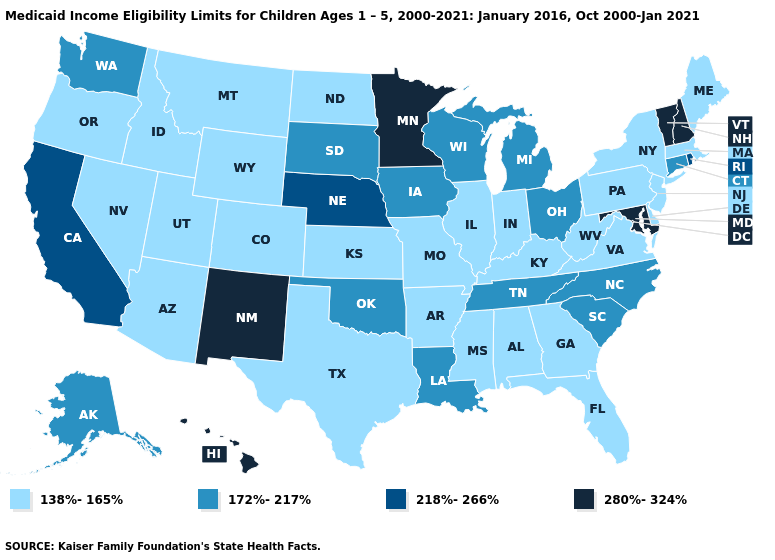Among the states that border New Mexico , which have the lowest value?
Write a very short answer. Arizona, Colorado, Texas, Utah. What is the value of Massachusetts?
Quick response, please. 138%-165%. Among the states that border Vermont , does New York have the highest value?
Write a very short answer. No. What is the highest value in the West ?
Be succinct. 280%-324%. What is the value of Washington?
Be succinct. 172%-217%. Does Maryland have the highest value in the South?
Give a very brief answer. Yes. What is the value of New Jersey?
Keep it brief. 138%-165%. Does New Jersey have the highest value in the USA?
Concise answer only. No. What is the highest value in the South ?
Keep it brief. 280%-324%. What is the value of Virginia?
Concise answer only. 138%-165%. Among the states that border West Virginia , which have the highest value?
Be succinct. Maryland. Name the states that have a value in the range 280%-324%?
Concise answer only. Hawaii, Maryland, Minnesota, New Hampshire, New Mexico, Vermont. Among the states that border New York , does New Jersey have the highest value?
Keep it brief. No. Does Hawaii have the highest value in the USA?
Give a very brief answer. Yes. What is the lowest value in the MidWest?
Keep it brief. 138%-165%. 